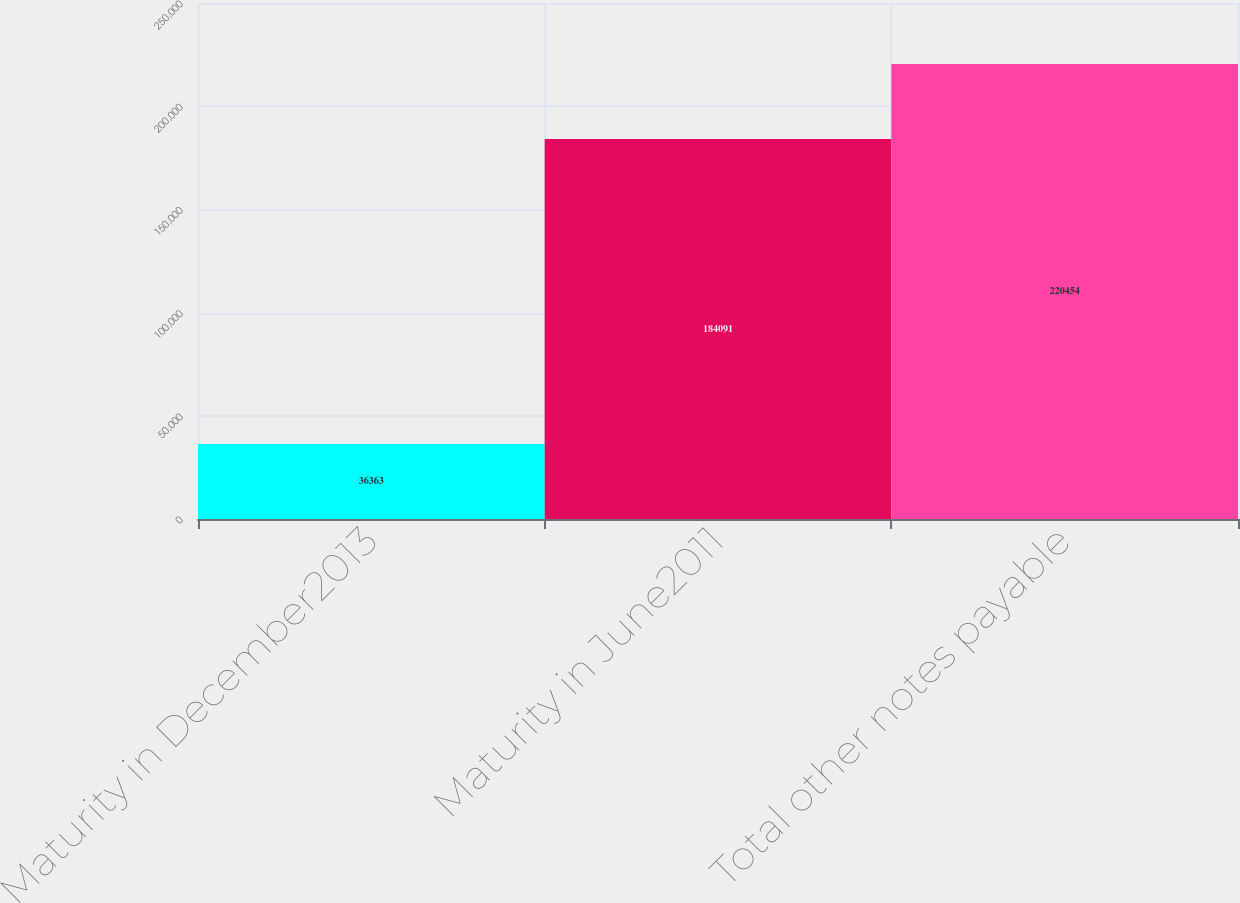Convert chart to OTSL. <chart><loc_0><loc_0><loc_500><loc_500><bar_chart><fcel>Maturity in December2013<fcel>Maturity in June2011<fcel>Total other notes payable<nl><fcel>36363<fcel>184091<fcel>220454<nl></chart> 